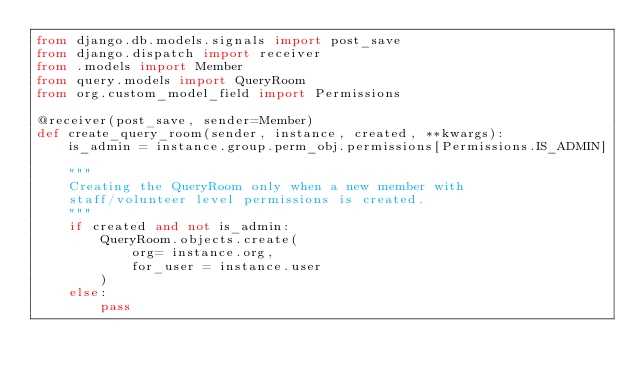Convert code to text. <code><loc_0><loc_0><loc_500><loc_500><_Python_>from django.db.models.signals import post_save
from django.dispatch import receiver
from .models import Member
from query.models import QueryRoom
from org.custom_model_field import Permissions

@receiver(post_save, sender=Member)
def create_query_room(sender, instance, created, **kwargs):
    is_admin = instance.group.perm_obj.permissions[Permissions.IS_ADMIN]

    """
    Creating the QueryRoom only when a new member with 
    staff/volunteer level permissions is created.
    """
    if created and not is_admin:
        QueryRoom.objects.create(
            org= instance.org,
            for_user = instance.user
        )
    else:
        pass
</code> 